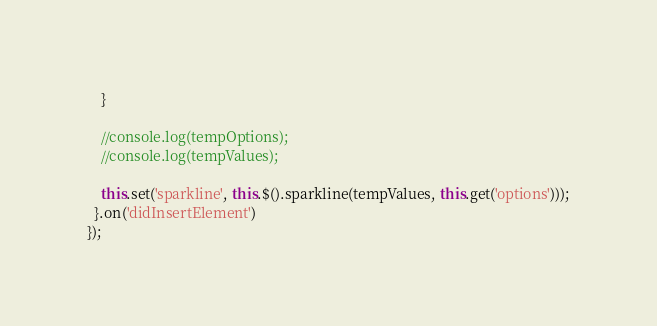Convert code to text. <code><loc_0><loc_0><loc_500><loc_500><_JavaScript_>    }

    //console.log(tempOptions);
    //console.log(tempValues);

    this.set('sparkline', this.$().sparkline(tempValues, this.get('options')));
  }.on('didInsertElement')
});
</code> 